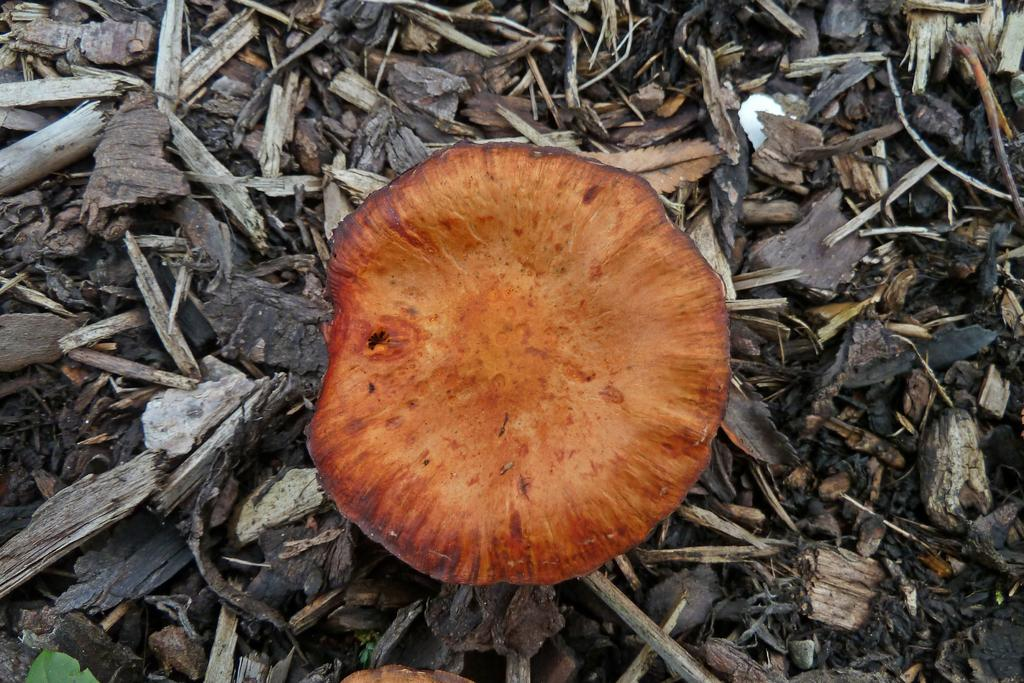What is the main object in the center of the image? There is a wood trunk in the center of the image. What can be seen in the background of the image? Wood pieces are present in the background of the image. Are there any bears interacting with the wood trunk in the image? There are no bears present in the image; it only features a wood trunk and wood pieces in the background. What design is visible on the wood trunk in the image? The wood trunk in the image does not have any visible design; it is a plain wooden trunk. 